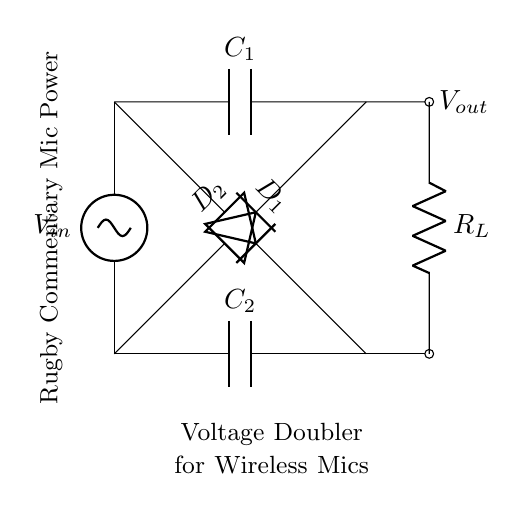What is the input voltage for this circuit? The input voltage (labeled V in) is represented on the left side of the circuit, indicated as V in, but an exact numerical value isn't provided in the diagram itself, so it stays as a variable.
Answer: V in What type of components are D1 and D2? D1 and D2 are both diodes, which enforce current to only flow in one direction, hence they are essential in rectifying the AC input to DC output.
Answer: Diodes What is the function of capacitor C1? C1 is connected in parallel to the output and charges up when the input is positive, storing energy to contribute to the voltage doubling effect of the circuit and providing smoothing of the output voltage.
Answer: Energy storage How many capacitors are present in this circuit? There are two capacitors in the circuit, labeled as C1 and C2, serving to filter and smooth out the voltage.
Answer: 2 What is the role of the load resistor R_L? R_L acts as the load, consuming power from the output side of the circuit, which represents the connected wireless microphone. It is vital for understanding how the circuit supplies energy to actual devices.
Answer: Load What is the output voltage relative to the input voltage in this circuit? The output voltage is roughly double the input voltage due to the voltage doubling effect created by the arrangement of diodes and capacitors in the circuit.
Answer: Twice the input voltage How does this circuit rectify the AC input? The circuit rectifies the AC input by using pairs of diodes (D1 and D2) to allow current flow only in one direction, thus converting AC to DC while simultaneously charging the capacitors to create a higher voltage output.
Answer: By using diodes 